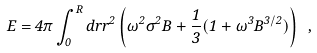<formula> <loc_0><loc_0><loc_500><loc_500>E = 4 \pi \int _ { 0 } ^ { R } d r r ^ { 2 } \left ( { \omega } ^ { 2 } { \sigma } ^ { 2 } B + \frac { 1 } { 3 } ( 1 + { \omega } ^ { 3 } B ^ { 3 / 2 } ) \right ) \ ,</formula> 